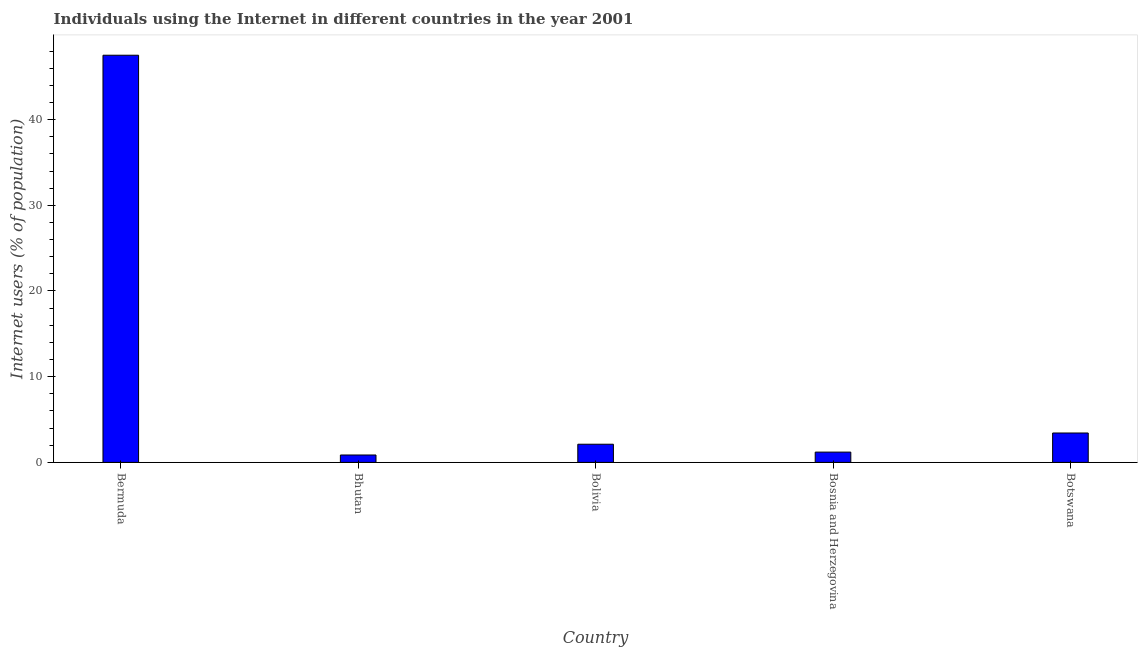Does the graph contain any zero values?
Offer a very short reply. No. Does the graph contain grids?
Give a very brief answer. No. What is the title of the graph?
Make the answer very short. Individuals using the Internet in different countries in the year 2001. What is the label or title of the Y-axis?
Ensure brevity in your answer.  Internet users (% of population). What is the number of internet users in Bhutan?
Make the answer very short. 0.86. Across all countries, what is the maximum number of internet users?
Provide a short and direct response. 47.51. Across all countries, what is the minimum number of internet users?
Your answer should be compact. 0.86. In which country was the number of internet users maximum?
Keep it short and to the point. Bermuda. In which country was the number of internet users minimum?
Offer a terse response. Bhutan. What is the sum of the number of internet users?
Ensure brevity in your answer.  55.13. What is the difference between the number of internet users in Bhutan and Bosnia and Herzegovina?
Make the answer very short. -0.34. What is the average number of internet users per country?
Provide a succinct answer. 11.03. What is the median number of internet users?
Offer a very short reply. 2.12. What is the ratio of the number of internet users in Bermuda to that in Bosnia and Herzegovina?
Make the answer very short. 39.57. What is the difference between the highest and the second highest number of internet users?
Offer a terse response. 44.08. Is the sum of the number of internet users in Bermuda and Bosnia and Herzegovina greater than the maximum number of internet users across all countries?
Provide a short and direct response. Yes. What is the difference between the highest and the lowest number of internet users?
Offer a terse response. 46.65. How many bars are there?
Your answer should be very brief. 5. Are all the bars in the graph horizontal?
Your answer should be compact. No. Are the values on the major ticks of Y-axis written in scientific E-notation?
Make the answer very short. No. What is the Internet users (% of population) of Bermuda?
Ensure brevity in your answer.  47.51. What is the Internet users (% of population) of Bhutan?
Provide a succinct answer. 0.86. What is the Internet users (% of population) in Bolivia?
Your answer should be compact. 2.12. What is the Internet users (% of population) in Bosnia and Herzegovina?
Offer a terse response. 1.2. What is the Internet users (% of population) of Botswana?
Make the answer very short. 3.43. What is the difference between the Internet users (% of population) in Bermuda and Bhutan?
Your answer should be compact. 46.65. What is the difference between the Internet users (% of population) in Bermuda and Bolivia?
Your answer should be very brief. 45.39. What is the difference between the Internet users (% of population) in Bermuda and Bosnia and Herzegovina?
Ensure brevity in your answer.  46.31. What is the difference between the Internet users (% of population) in Bermuda and Botswana?
Give a very brief answer. 44.08. What is the difference between the Internet users (% of population) in Bhutan and Bolivia?
Your response must be concise. -1.26. What is the difference between the Internet users (% of population) in Bhutan and Bosnia and Herzegovina?
Your answer should be very brief. -0.34. What is the difference between the Internet users (% of population) in Bhutan and Botswana?
Make the answer very short. -2.57. What is the difference between the Internet users (% of population) in Bolivia and Bosnia and Herzegovina?
Ensure brevity in your answer.  0.92. What is the difference between the Internet users (% of population) in Bolivia and Botswana?
Your answer should be very brief. -1.31. What is the difference between the Internet users (% of population) in Bosnia and Herzegovina and Botswana?
Your answer should be very brief. -2.23. What is the ratio of the Internet users (% of population) in Bermuda to that in Bhutan?
Make the answer very short. 54.95. What is the ratio of the Internet users (% of population) in Bermuda to that in Bolivia?
Provide a succinct answer. 22.41. What is the ratio of the Internet users (% of population) in Bermuda to that in Bosnia and Herzegovina?
Ensure brevity in your answer.  39.57. What is the ratio of the Internet users (% of population) in Bermuda to that in Botswana?
Ensure brevity in your answer.  13.85. What is the ratio of the Internet users (% of population) in Bhutan to that in Bolivia?
Give a very brief answer. 0.41. What is the ratio of the Internet users (% of population) in Bhutan to that in Bosnia and Herzegovina?
Provide a short and direct response. 0.72. What is the ratio of the Internet users (% of population) in Bhutan to that in Botswana?
Provide a short and direct response. 0.25. What is the ratio of the Internet users (% of population) in Bolivia to that in Bosnia and Herzegovina?
Provide a short and direct response. 1.77. What is the ratio of the Internet users (% of population) in Bolivia to that in Botswana?
Your answer should be compact. 0.62. What is the ratio of the Internet users (% of population) in Bosnia and Herzegovina to that in Botswana?
Provide a short and direct response. 0.35. 